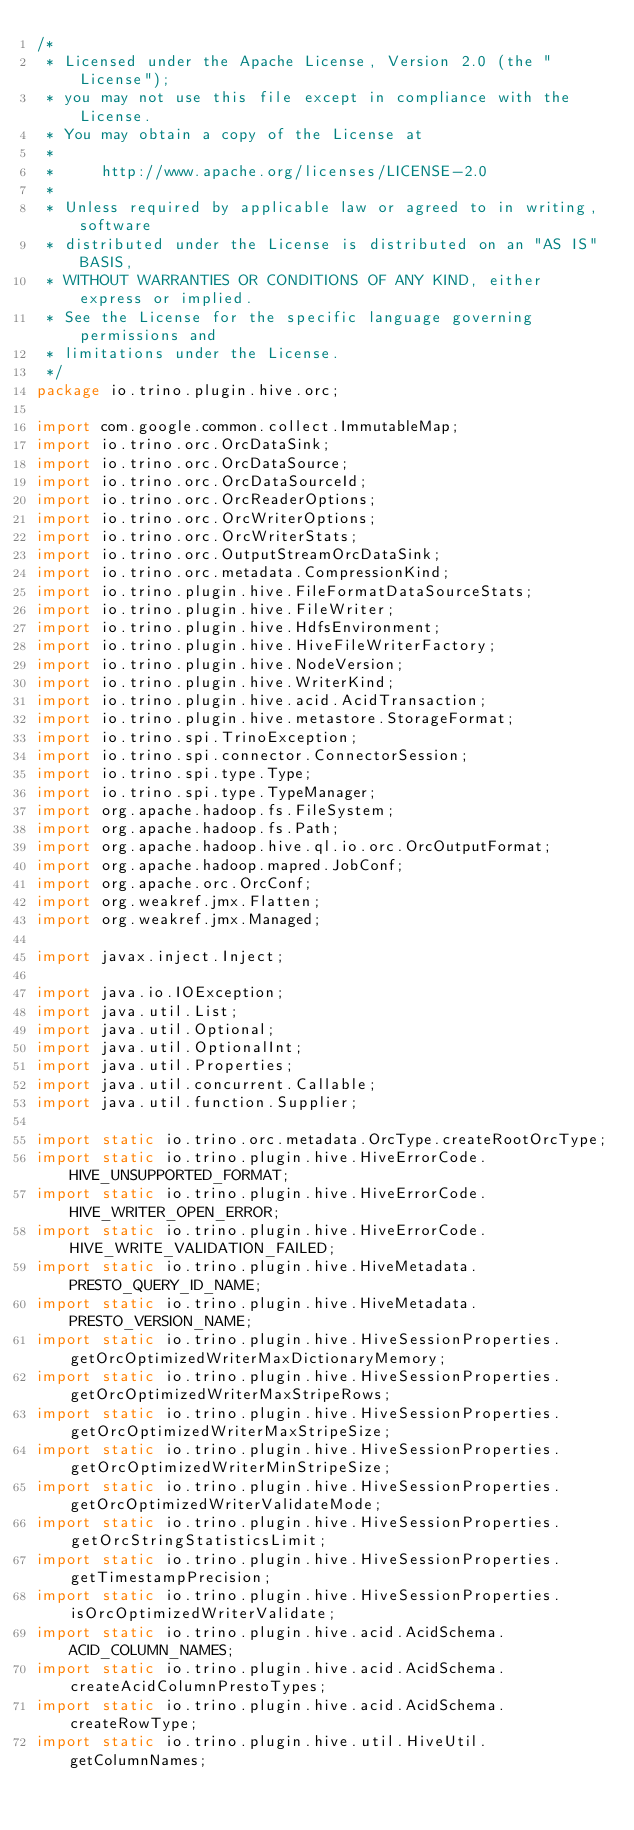Convert code to text. <code><loc_0><loc_0><loc_500><loc_500><_Java_>/*
 * Licensed under the Apache License, Version 2.0 (the "License");
 * you may not use this file except in compliance with the License.
 * You may obtain a copy of the License at
 *
 *     http://www.apache.org/licenses/LICENSE-2.0
 *
 * Unless required by applicable law or agreed to in writing, software
 * distributed under the License is distributed on an "AS IS" BASIS,
 * WITHOUT WARRANTIES OR CONDITIONS OF ANY KIND, either express or implied.
 * See the License for the specific language governing permissions and
 * limitations under the License.
 */
package io.trino.plugin.hive.orc;

import com.google.common.collect.ImmutableMap;
import io.trino.orc.OrcDataSink;
import io.trino.orc.OrcDataSource;
import io.trino.orc.OrcDataSourceId;
import io.trino.orc.OrcReaderOptions;
import io.trino.orc.OrcWriterOptions;
import io.trino.orc.OrcWriterStats;
import io.trino.orc.OutputStreamOrcDataSink;
import io.trino.orc.metadata.CompressionKind;
import io.trino.plugin.hive.FileFormatDataSourceStats;
import io.trino.plugin.hive.FileWriter;
import io.trino.plugin.hive.HdfsEnvironment;
import io.trino.plugin.hive.HiveFileWriterFactory;
import io.trino.plugin.hive.NodeVersion;
import io.trino.plugin.hive.WriterKind;
import io.trino.plugin.hive.acid.AcidTransaction;
import io.trino.plugin.hive.metastore.StorageFormat;
import io.trino.spi.TrinoException;
import io.trino.spi.connector.ConnectorSession;
import io.trino.spi.type.Type;
import io.trino.spi.type.TypeManager;
import org.apache.hadoop.fs.FileSystem;
import org.apache.hadoop.fs.Path;
import org.apache.hadoop.hive.ql.io.orc.OrcOutputFormat;
import org.apache.hadoop.mapred.JobConf;
import org.apache.orc.OrcConf;
import org.weakref.jmx.Flatten;
import org.weakref.jmx.Managed;

import javax.inject.Inject;

import java.io.IOException;
import java.util.List;
import java.util.Optional;
import java.util.OptionalInt;
import java.util.Properties;
import java.util.concurrent.Callable;
import java.util.function.Supplier;

import static io.trino.orc.metadata.OrcType.createRootOrcType;
import static io.trino.plugin.hive.HiveErrorCode.HIVE_UNSUPPORTED_FORMAT;
import static io.trino.plugin.hive.HiveErrorCode.HIVE_WRITER_OPEN_ERROR;
import static io.trino.plugin.hive.HiveErrorCode.HIVE_WRITE_VALIDATION_FAILED;
import static io.trino.plugin.hive.HiveMetadata.PRESTO_QUERY_ID_NAME;
import static io.trino.plugin.hive.HiveMetadata.PRESTO_VERSION_NAME;
import static io.trino.plugin.hive.HiveSessionProperties.getOrcOptimizedWriterMaxDictionaryMemory;
import static io.trino.plugin.hive.HiveSessionProperties.getOrcOptimizedWriterMaxStripeRows;
import static io.trino.plugin.hive.HiveSessionProperties.getOrcOptimizedWriterMaxStripeSize;
import static io.trino.plugin.hive.HiveSessionProperties.getOrcOptimizedWriterMinStripeSize;
import static io.trino.plugin.hive.HiveSessionProperties.getOrcOptimizedWriterValidateMode;
import static io.trino.plugin.hive.HiveSessionProperties.getOrcStringStatisticsLimit;
import static io.trino.plugin.hive.HiveSessionProperties.getTimestampPrecision;
import static io.trino.plugin.hive.HiveSessionProperties.isOrcOptimizedWriterValidate;
import static io.trino.plugin.hive.acid.AcidSchema.ACID_COLUMN_NAMES;
import static io.trino.plugin.hive.acid.AcidSchema.createAcidColumnPrestoTypes;
import static io.trino.plugin.hive.acid.AcidSchema.createRowType;
import static io.trino.plugin.hive.util.HiveUtil.getColumnNames;</code> 